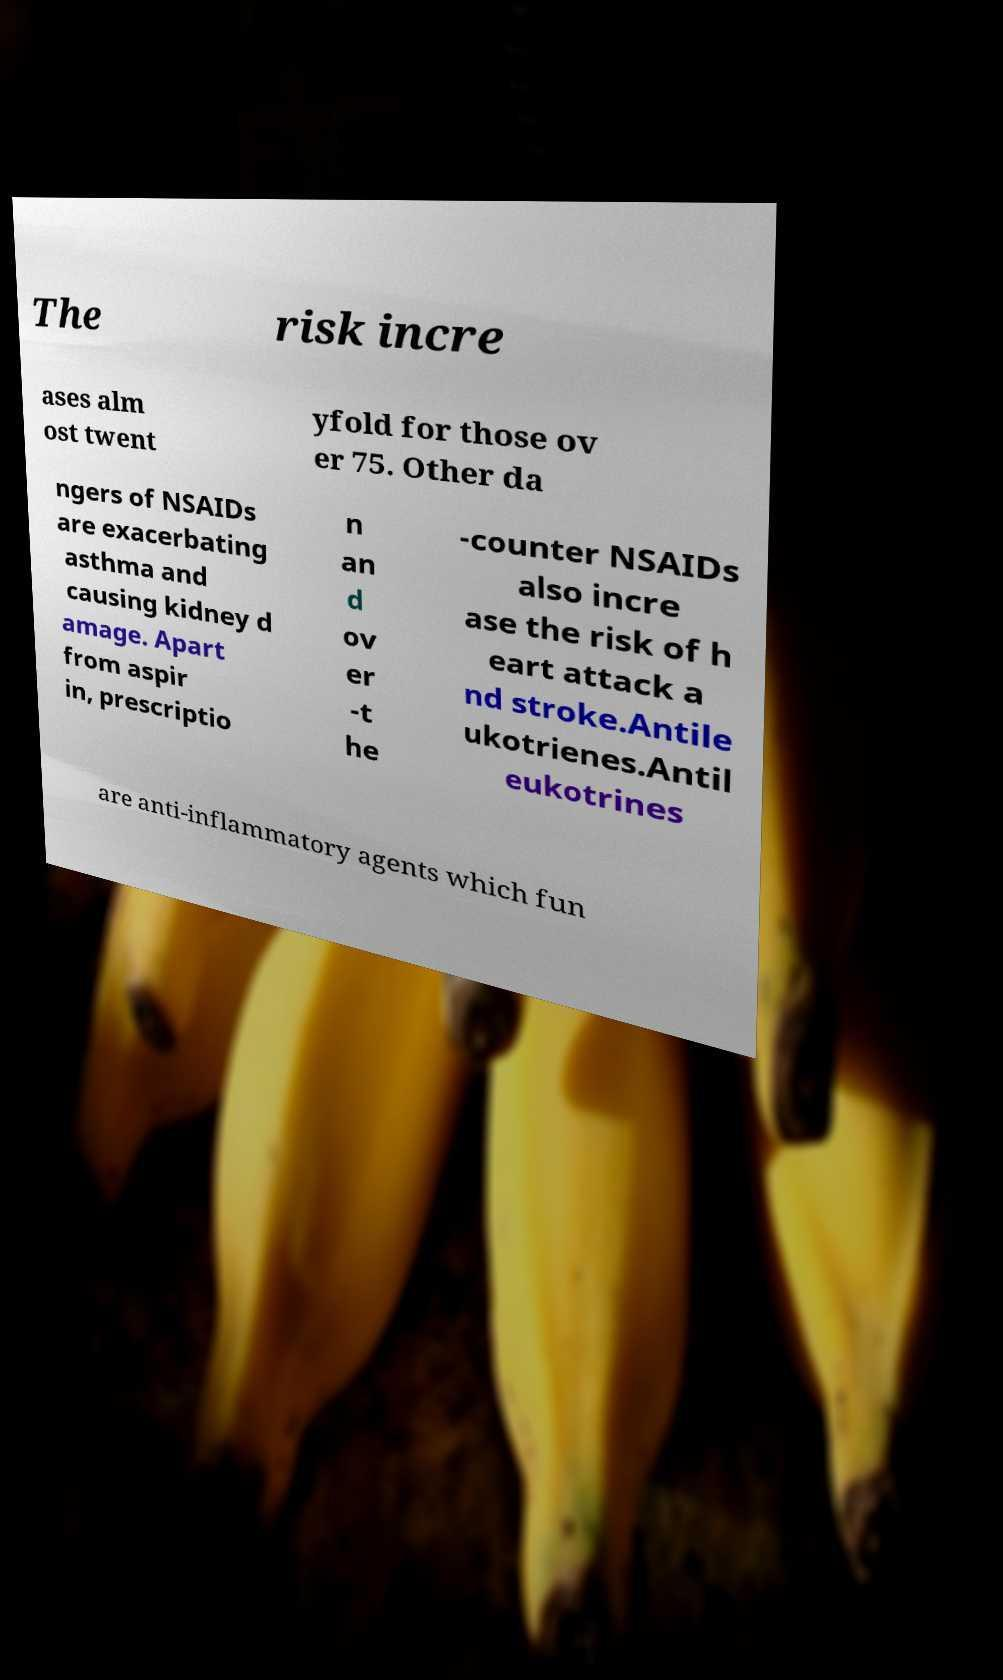Can you explain what Antileukotrienes are, based on the image? Based on the snippet visible in the image, Antileukotrienes are described as anti-inflammatory agents. While the text does not provide a full explanation, these are generally used to treat asthma by blocking leukotrienes — chemicals in the immune system that contribute to inflammation, bronchoconstriction, and mucus production. 